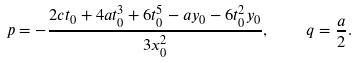Convert formula to latex. <formula><loc_0><loc_0><loc_500><loc_500>p = - \frac { 2 c t _ { 0 } + 4 a t _ { 0 } ^ { 3 } + 6 t _ { 0 } ^ { 5 } - a y _ { 0 } - 6 t _ { 0 } ^ { 2 } y _ { 0 } } { 3 x _ { 0 } ^ { 2 } } , \quad q = \frac { a } { 2 } .</formula> 